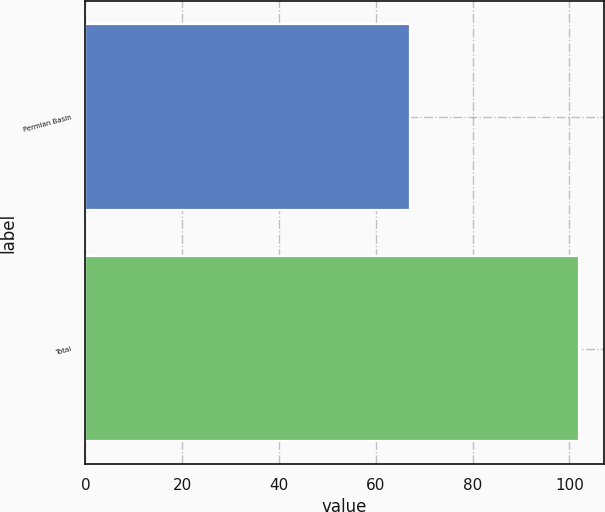Convert chart. <chart><loc_0><loc_0><loc_500><loc_500><bar_chart><fcel>Permian Basin<fcel>Total<nl><fcel>67<fcel>102<nl></chart> 